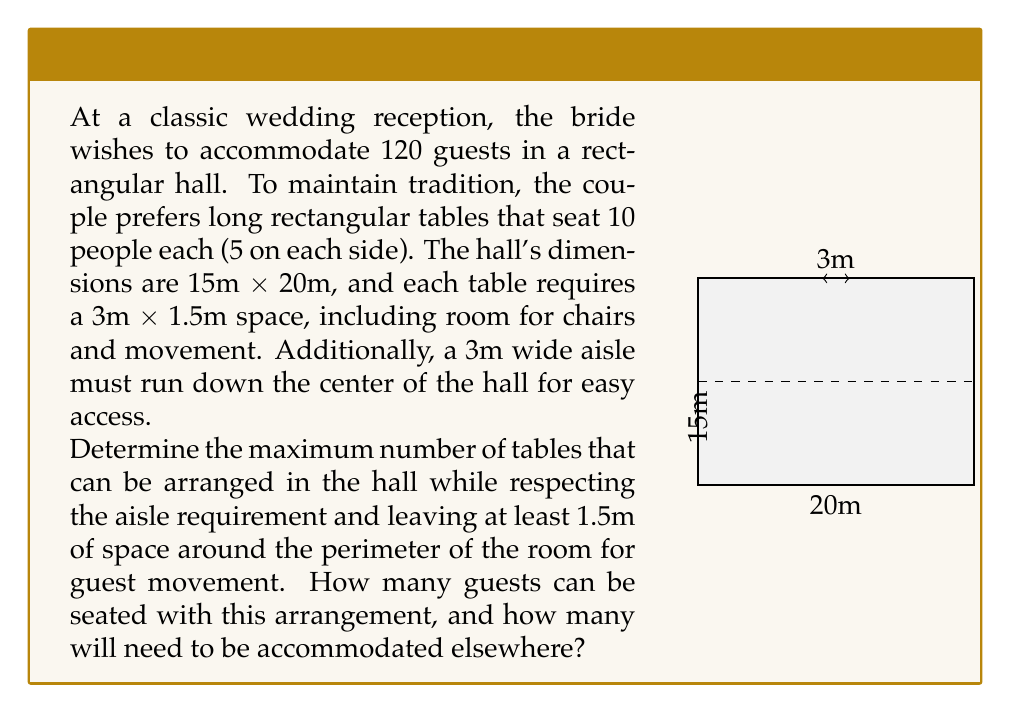Can you solve this math problem? Let's approach this problem step-by-step:

1) First, we need to calculate the usable space in the hall:
   - Total width: 15m
   - Aisle width: 3m
   - Usable width on each side of the aisle: (15m - 3m) / 2 = 6m

2) Now, let's consider the space needed for each table:
   - Table space: 3m x 1.5m
   - We need to place tables along the 20m length of the hall

3) Calculate how many tables can fit on each side of the aisle:
   - Available length: 20m - 2(1.5m) = 17m (subtracting 1.5m from each end for movement)
   - Number of tables per side: 17m / 3m = 5.67
   - We can fit 5 tables on each side

4) Total number of tables:
   $$ \text{Total tables} = 5 \text{ tables} \times 2 \text{ sides} = 10 \text{ tables} $$

5) Calculate the number of guests that can be seated:
   $$ \text{Seated guests} = 10 \text{ tables} \times 10 \text{ guests per table} = 100 \text{ guests} $$

6) Determine the number of guests that need to be accommodated elsewhere:
   $$ \text{Remaining guests} = 120 \text{ total guests} - 100 \text{ seated guests} = 20 \text{ guests} $$

Therefore, the maximum number of tables that can be arranged is 10, seating 100 guests, with 20 guests needing to be accommodated elsewhere.
Answer: 10 tables; 100 seated guests; 20 guests elsewhere 